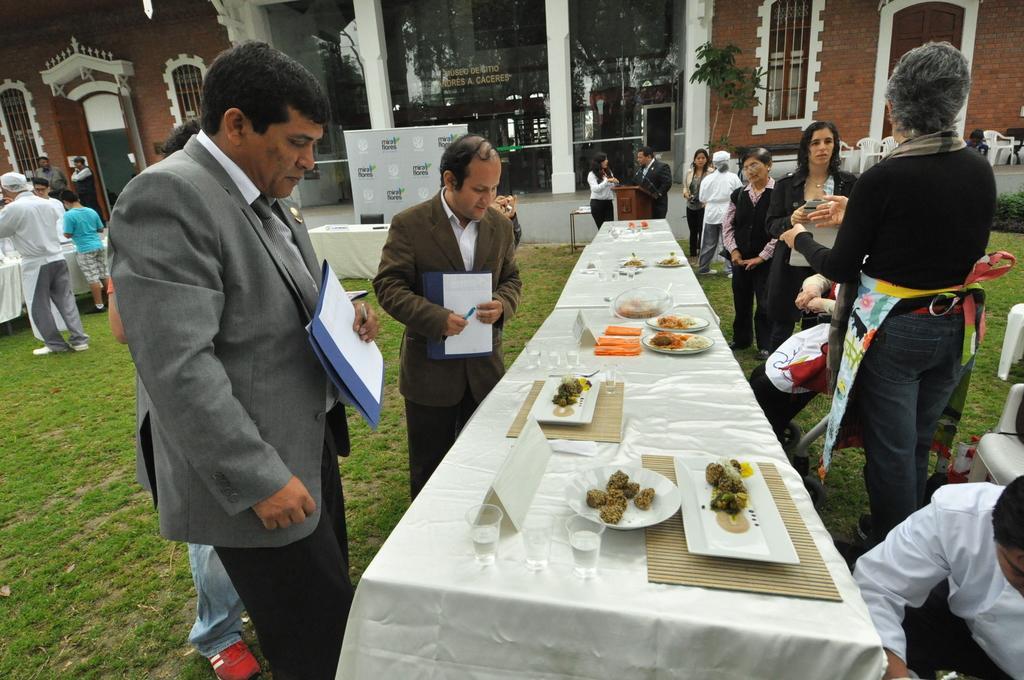How would you summarize this image in a sentence or two? In this image there are group of person standing and walking. In the center there is a table which is covered with a white colour cloth. On the table there are some foods on plates, Glasses, and at the left the person standing is holding a paper in his hand. In the center person wearing brown colour suit is holding a paper and pen in his hand. In the background there are glasses and building, door. On the floor there is a Grass. 